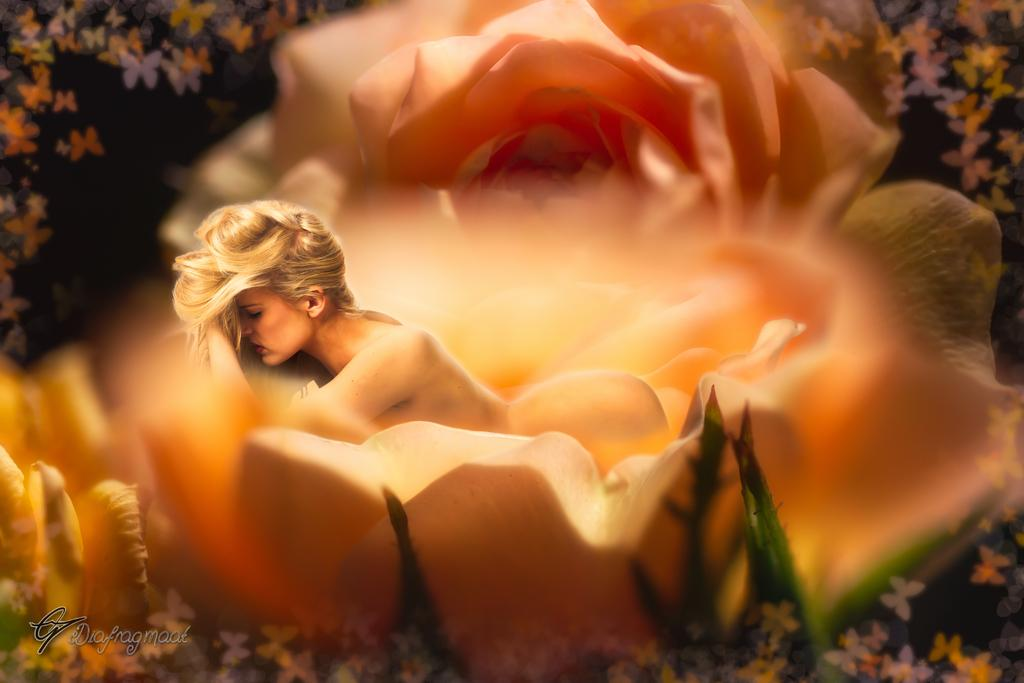What type of image is being described? The image is an animated image. What is the lady doing in the image? The lady is lying inside a rose flower in the image. What can be seen in the background of the image? There are butterflies in the background of the image. How many ants can be seen carrying luggage at the airport in the image? There are no ants or airport present in the image; it features a lady lying inside a rose flower with butterflies in the background. 